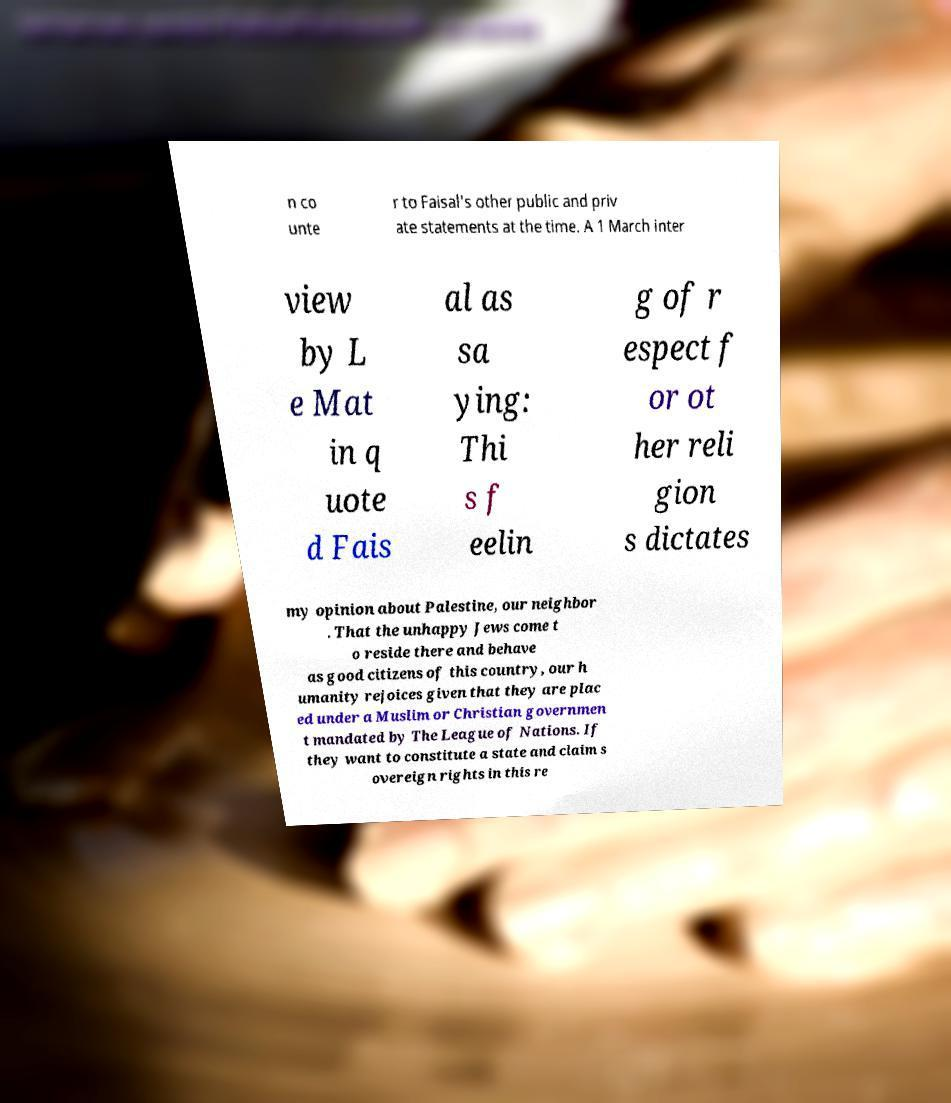For documentation purposes, I need the text within this image transcribed. Could you provide that? n co unte r to Faisal's other public and priv ate statements at the time. A 1 March inter view by L e Mat in q uote d Fais al as sa ying: Thi s f eelin g of r espect f or ot her reli gion s dictates my opinion about Palestine, our neighbor . That the unhappy Jews come t o reside there and behave as good citizens of this country, our h umanity rejoices given that they are plac ed under a Muslim or Christian governmen t mandated by The League of Nations. If they want to constitute a state and claim s overeign rights in this re 